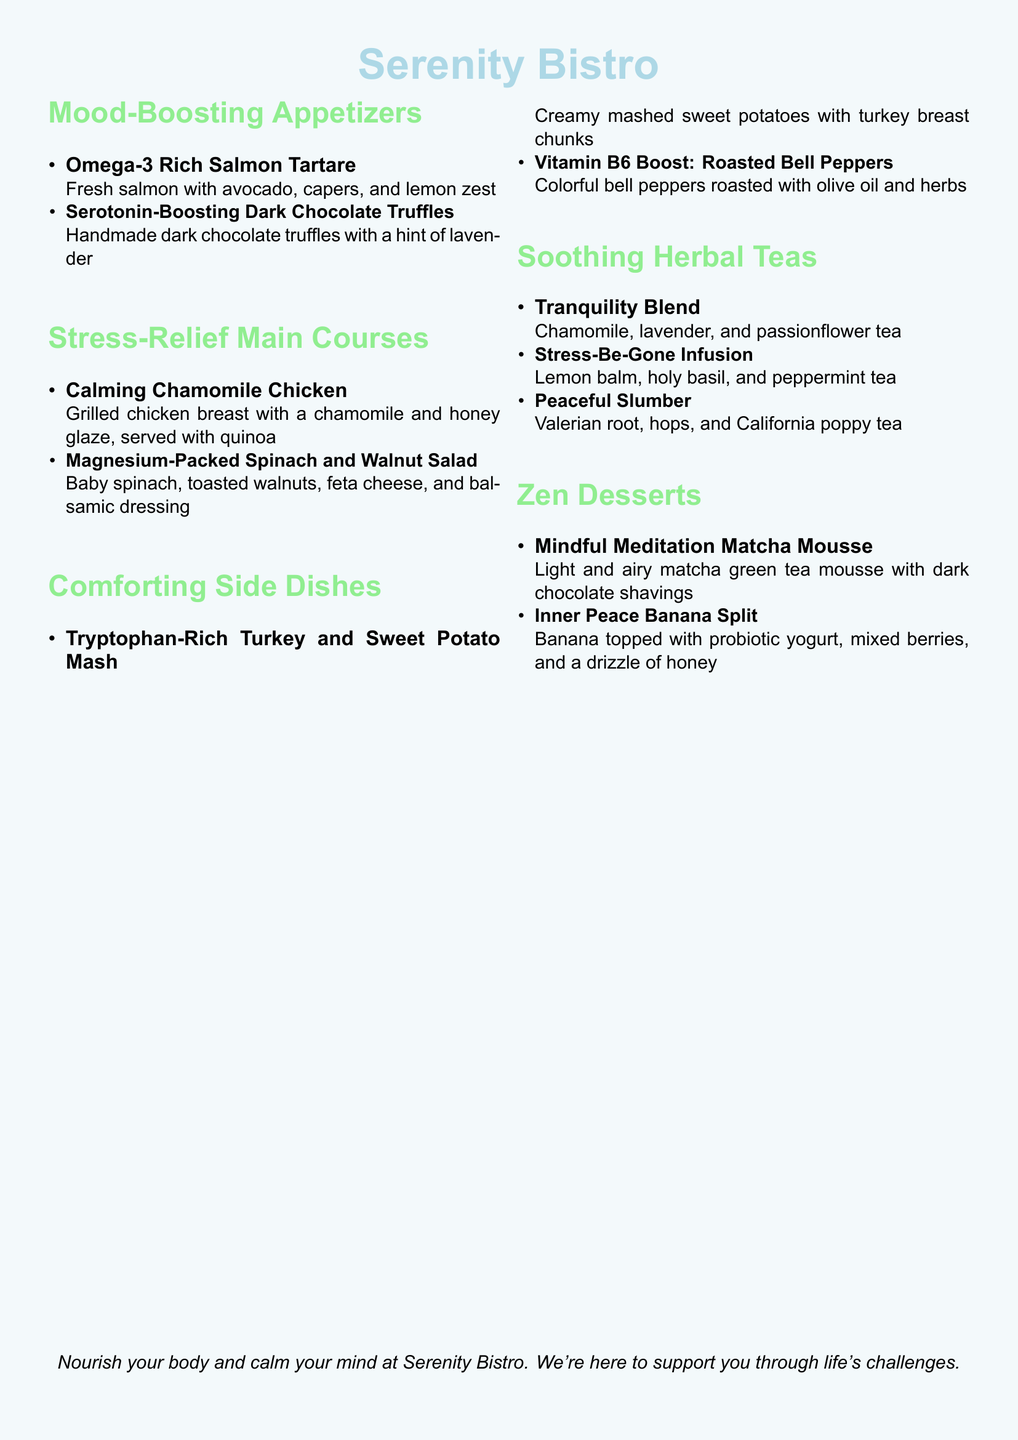What are the appetizers on the menu? The document lists two appetizers under the Mood-Boosting Appetizers section.
Answer: Omega-3 Rich Salmon Tartare, Serotonin-Boosting Dark Chocolate Truffles How many main course options are available? The document states that there are two main course options listed under the Stress-Relief Main Courses section.
Answer: 2 Which dessert features matcha? The document includes one dessert that features matcha in the Zen Desserts section.
Answer: Mindful Meditation Matcha Mousse What ingredient is used in the Tranquility Blend tea? The Tranquility Blend includes three specific ingredients as listed in the Soothing Herbal Teas section.
Answer: Chamomile, lavender, and passionflower Which mood-boosting ingredient is found in the salad? The Magnesium-Packed Spinach and Walnut Salad includes a specific mood-boosting ingredient, as noted in the Stress-Relief Main Courses section.
Answer: Spinach and walnuts 